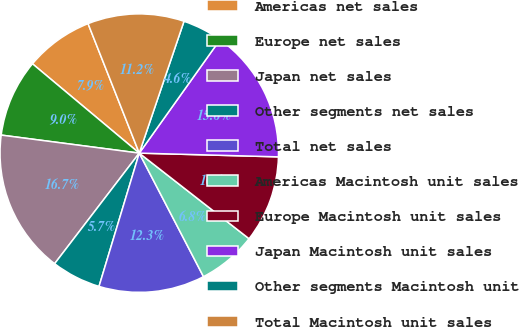<chart> <loc_0><loc_0><loc_500><loc_500><pie_chart><fcel>Americas net sales<fcel>Europe net sales<fcel>Japan net sales<fcel>Other segments net sales<fcel>Total net sales<fcel>Americas Macintosh unit sales<fcel>Europe Macintosh unit sales<fcel>Japan Macintosh unit sales<fcel>Other segments Macintosh unit<fcel>Total Macintosh unit sales<nl><fcel>7.92%<fcel>9.02%<fcel>16.67%<fcel>5.73%<fcel>12.3%<fcel>6.83%<fcel>10.11%<fcel>15.58%<fcel>4.64%<fcel>11.2%<nl></chart> 